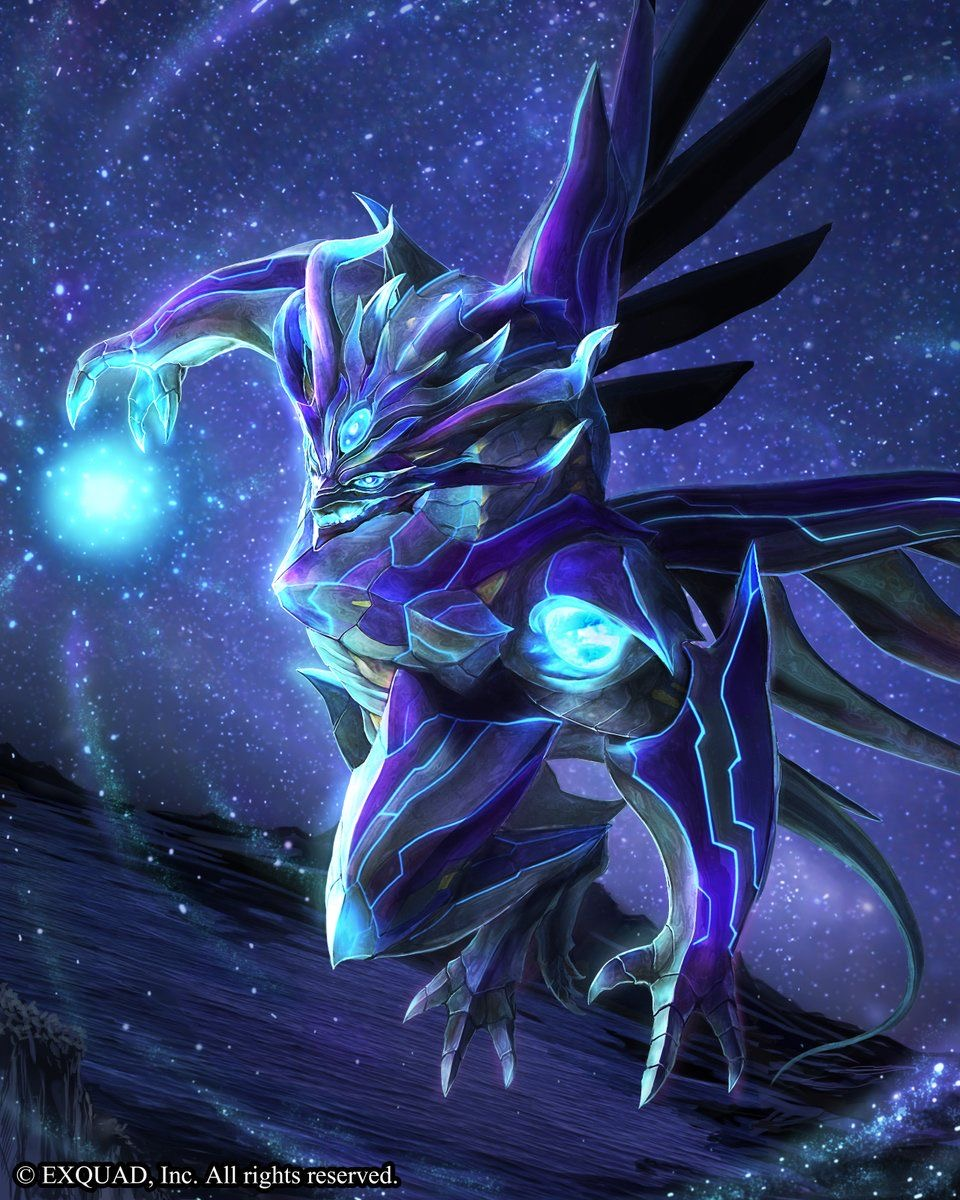analyze the image by giving the content, appearance and style of the image  ### Content:
The image features a person with a highly stylized and artistic appearance. Key elements include:

- **Hair**: Blonde braids with a voluminous updo. The hair is adorned with large, vibrant pink flowers.
- **Makeup**: The makeup is elaborate and colorful. The eyes are highlighted with green eye shadow extending above the brows and pink accents around the eyes and forehead. Pink dots decorate the face, and the lips are a glossy, deep red.
- **Accessories**: The person wears large, ornate silver hoop earrings and a necklace with a heart-shaped pendant that says "GIRL." There are also visible star tattoos on the shoulders.
- **Attire**: The clothing is light pink and shimmery, with a mesh-like texture visible on the shoulders.

### Appearance:
- **Overall Look**: The overall look is striking and bold, combining elements of fantasy and glamour.
- **Skin**: The skin appears smooth and luminous, with a shiny or glossy finish.
- **Expression**: The person has a confident and intense facial expression, with parted lips and direct eye contact with the camera.

### Style:
- **Artistic and Fantasy-Inspired**: The use of bright colors, floral elements, and detailed makeup suggests a fantasy or artistic style. It may be reminiscent of themes often seen in high-fashion editorials or cosplay.
- **Glamorous**: The glossy makeup and metallic accessories add a touch of glamour.
- **Creative and Bold**: The combination of elements such as the floral hairpiece, elaborate makeup, and statement jewelry all point to a highly creative and bold style, likely intended to make a strong visual impact. Come up with a description for the content of this image (make it {extreme knowledge}, no more than 9 words!), while also describing the style of this image in detail. For the latter, look at the texture carefully to determine the techniqe used. Be specific. In that part, mention the style and exact content. Briefly describe the style as aptly as possible, don't say 'likely', make an straight forward response, giving great emphasis on the techniques used to generate such an image (dark fantasy artwork, for example, or max knowledge detail/ every exact even small details in the image), including details about how sparse/minimal or complex it is. Then provide your response in the following format, always using a | to separate the new content idea from the style descriptions: <content in the image>, | <details>, <small details>, <exact look and feel>, <colors used>. You will be inclined to say 'digital' if you're not sure, please only do that when you're certain, and go into full detail first. Alien creature wielding energy orb | Digital fantasy illustration, intricate and luminous. Detailed textures with glowing highlights and sharp edges. The creature is adorned with armor-like plating and glowing blue and purple hues. The background is a starry, cosmic expanse. 